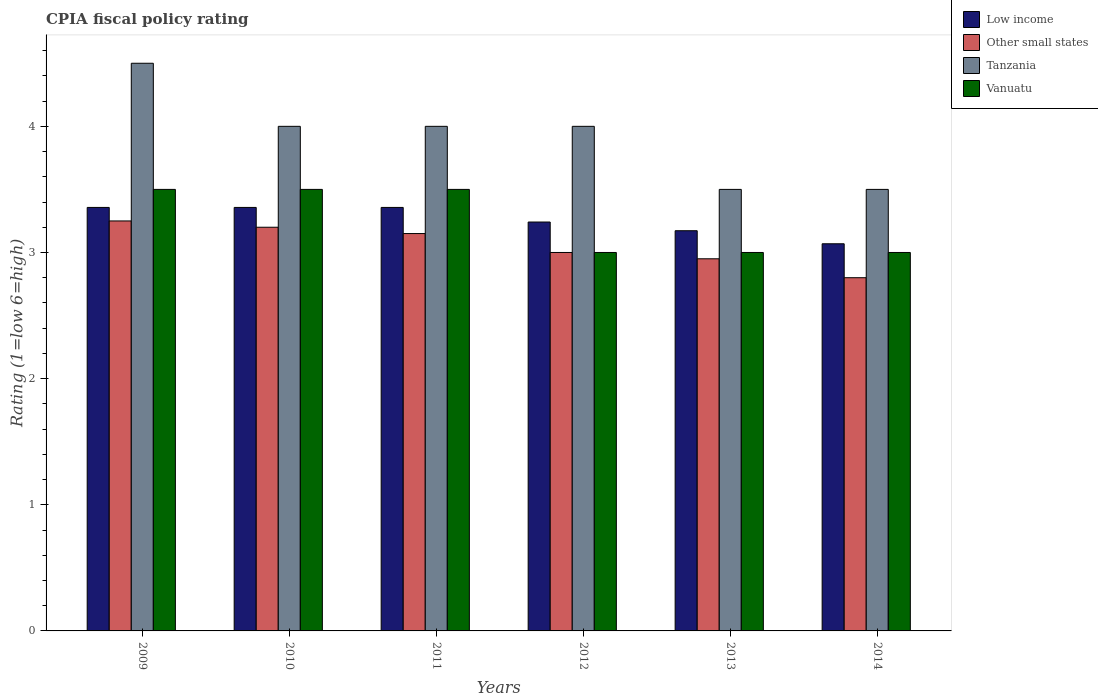Are the number of bars per tick equal to the number of legend labels?
Your answer should be very brief. Yes. How many bars are there on the 1st tick from the left?
Your response must be concise. 4. Across all years, what is the maximum CPIA rating in Vanuatu?
Give a very brief answer. 3.5. Across all years, what is the minimum CPIA rating in Tanzania?
Your answer should be very brief. 3.5. What is the total CPIA rating in Other small states in the graph?
Provide a succinct answer. 18.35. What is the difference between the CPIA rating in Low income in 2009 and that in 2014?
Keep it short and to the point. 0.29. What is the difference between the CPIA rating in Other small states in 2010 and the CPIA rating in Tanzania in 2013?
Provide a short and direct response. -0.3. In the year 2012, what is the difference between the CPIA rating in Tanzania and CPIA rating in Other small states?
Make the answer very short. 1. Is the CPIA rating in Vanuatu in 2010 less than that in 2012?
Offer a terse response. No. Is the difference between the CPIA rating in Tanzania in 2009 and 2010 greater than the difference between the CPIA rating in Other small states in 2009 and 2010?
Your response must be concise. Yes. What is the difference between the highest and the second highest CPIA rating in Tanzania?
Your response must be concise. 0.5. What is the difference between the highest and the lowest CPIA rating in Vanuatu?
Give a very brief answer. 0.5. In how many years, is the CPIA rating in Other small states greater than the average CPIA rating in Other small states taken over all years?
Your answer should be very brief. 3. What does the 2nd bar from the left in 2011 represents?
Provide a succinct answer. Other small states. What does the 1st bar from the right in 2011 represents?
Your response must be concise. Vanuatu. Is it the case that in every year, the sum of the CPIA rating in Low income and CPIA rating in Tanzania is greater than the CPIA rating in Vanuatu?
Make the answer very short. Yes. How many years are there in the graph?
Your answer should be compact. 6. Are the values on the major ticks of Y-axis written in scientific E-notation?
Your answer should be compact. No. Does the graph contain any zero values?
Offer a terse response. No. Where does the legend appear in the graph?
Your response must be concise. Top right. How many legend labels are there?
Your answer should be compact. 4. How are the legend labels stacked?
Provide a succinct answer. Vertical. What is the title of the graph?
Provide a succinct answer. CPIA fiscal policy rating. Does "Sri Lanka" appear as one of the legend labels in the graph?
Your answer should be very brief. No. What is the label or title of the X-axis?
Ensure brevity in your answer.  Years. What is the label or title of the Y-axis?
Your answer should be very brief. Rating (1=low 6=high). What is the Rating (1=low 6=high) of Low income in 2009?
Ensure brevity in your answer.  3.36. What is the Rating (1=low 6=high) in Other small states in 2009?
Provide a short and direct response. 3.25. What is the Rating (1=low 6=high) in Tanzania in 2009?
Offer a terse response. 4.5. What is the Rating (1=low 6=high) in Vanuatu in 2009?
Give a very brief answer. 3.5. What is the Rating (1=low 6=high) of Low income in 2010?
Give a very brief answer. 3.36. What is the Rating (1=low 6=high) of Other small states in 2010?
Give a very brief answer. 3.2. What is the Rating (1=low 6=high) of Low income in 2011?
Ensure brevity in your answer.  3.36. What is the Rating (1=low 6=high) of Other small states in 2011?
Keep it short and to the point. 3.15. What is the Rating (1=low 6=high) in Tanzania in 2011?
Provide a succinct answer. 4. What is the Rating (1=low 6=high) of Vanuatu in 2011?
Your answer should be compact. 3.5. What is the Rating (1=low 6=high) in Low income in 2012?
Offer a very short reply. 3.24. What is the Rating (1=low 6=high) in Vanuatu in 2012?
Ensure brevity in your answer.  3. What is the Rating (1=low 6=high) in Low income in 2013?
Your answer should be very brief. 3.17. What is the Rating (1=low 6=high) of Other small states in 2013?
Your response must be concise. 2.95. What is the Rating (1=low 6=high) of Vanuatu in 2013?
Your answer should be very brief. 3. What is the Rating (1=low 6=high) in Low income in 2014?
Offer a terse response. 3.07. What is the Rating (1=low 6=high) of Tanzania in 2014?
Offer a very short reply. 3.5. What is the Rating (1=low 6=high) in Vanuatu in 2014?
Your answer should be very brief. 3. Across all years, what is the maximum Rating (1=low 6=high) in Low income?
Offer a very short reply. 3.36. Across all years, what is the maximum Rating (1=low 6=high) of Tanzania?
Provide a succinct answer. 4.5. Across all years, what is the minimum Rating (1=low 6=high) in Low income?
Provide a succinct answer. 3.07. Across all years, what is the minimum Rating (1=low 6=high) of Tanzania?
Ensure brevity in your answer.  3.5. Across all years, what is the minimum Rating (1=low 6=high) in Vanuatu?
Your answer should be compact. 3. What is the total Rating (1=low 6=high) in Low income in the graph?
Your answer should be very brief. 19.55. What is the total Rating (1=low 6=high) of Other small states in the graph?
Offer a very short reply. 18.35. What is the total Rating (1=low 6=high) in Tanzania in the graph?
Provide a succinct answer. 23.5. What is the total Rating (1=low 6=high) in Vanuatu in the graph?
Give a very brief answer. 19.5. What is the difference between the Rating (1=low 6=high) in Other small states in 2009 and that in 2010?
Make the answer very short. 0.05. What is the difference between the Rating (1=low 6=high) in Tanzania in 2009 and that in 2011?
Make the answer very short. 0.5. What is the difference between the Rating (1=low 6=high) of Low income in 2009 and that in 2012?
Offer a terse response. 0.12. What is the difference between the Rating (1=low 6=high) of Other small states in 2009 and that in 2012?
Give a very brief answer. 0.25. What is the difference between the Rating (1=low 6=high) of Tanzania in 2009 and that in 2012?
Give a very brief answer. 0.5. What is the difference between the Rating (1=low 6=high) in Vanuatu in 2009 and that in 2012?
Your response must be concise. 0.5. What is the difference between the Rating (1=low 6=high) of Low income in 2009 and that in 2013?
Provide a succinct answer. 0.18. What is the difference between the Rating (1=low 6=high) in Other small states in 2009 and that in 2013?
Ensure brevity in your answer.  0.3. What is the difference between the Rating (1=low 6=high) in Vanuatu in 2009 and that in 2013?
Keep it short and to the point. 0.5. What is the difference between the Rating (1=low 6=high) of Low income in 2009 and that in 2014?
Make the answer very short. 0.29. What is the difference between the Rating (1=low 6=high) in Other small states in 2009 and that in 2014?
Offer a very short reply. 0.45. What is the difference between the Rating (1=low 6=high) in Vanuatu in 2010 and that in 2011?
Your response must be concise. 0. What is the difference between the Rating (1=low 6=high) of Low income in 2010 and that in 2012?
Ensure brevity in your answer.  0.12. What is the difference between the Rating (1=low 6=high) of Other small states in 2010 and that in 2012?
Make the answer very short. 0.2. What is the difference between the Rating (1=low 6=high) in Low income in 2010 and that in 2013?
Provide a short and direct response. 0.18. What is the difference between the Rating (1=low 6=high) of Other small states in 2010 and that in 2013?
Offer a very short reply. 0.25. What is the difference between the Rating (1=low 6=high) of Low income in 2010 and that in 2014?
Give a very brief answer. 0.29. What is the difference between the Rating (1=low 6=high) in Tanzania in 2010 and that in 2014?
Give a very brief answer. 0.5. What is the difference between the Rating (1=low 6=high) of Vanuatu in 2010 and that in 2014?
Provide a succinct answer. 0.5. What is the difference between the Rating (1=low 6=high) of Low income in 2011 and that in 2012?
Ensure brevity in your answer.  0.12. What is the difference between the Rating (1=low 6=high) in Other small states in 2011 and that in 2012?
Give a very brief answer. 0.15. What is the difference between the Rating (1=low 6=high) in Tanzania in 2011 and that in 2012?
Ensure brevity in your answer.  0. What is the difference between the Rating (1=low 6=high) in Vanuatu in 2011 and that in 2012?
Your response must be concise. 0.5. What is the difference between the Rating (1=low 6=high) in Low income in 2011 and that in 2013?
Your response must be concise. 0.18. What is the difference between the Rating (1=low 6=high) in Other small states in 2011 and that in 2013?
Provide a short and direct response. 0.2. What is the difference between the Rating (1=low 6=high) in Vanuatu in 2011 and that in 2013?
Provide a short and direct response. 0.5. What is the difference between the Rating (1=low 6=high) of Low income in 2011 and that in 2014?
Ensure brevity in your answer.  0.29. What is the difference between the Rating (1=low 6=high) in Tanzania in 2011 and that in 2014?
Keep it short and to the point. 0.5. What is the difference between the Rating (1=low 6=high) in Low income in 2012 and that in 2013?
Offer a terse response. 0.07. What is the difference between the Rating (1=low 6=high) of Vanuatu in 2012 and that in 2013?
Keep it short and to the point. 0. What is the difference between the Rating (1=low 6=high) of Low income in 2012 and that in 2014?
Your response must be concise. 0.17. What is the difference between the Rating (1=low 6=high) in Other small states in 2012 and that in 2014?
Your response must be concise. 0.2. What is the difference between the Rating (1=low 6=high) in Tanzania in 2012 and that in 2014?
Provide a succinct answer. 0.5. What is the difference between the Rating (1=low 6=high) in Low income in 2013 and that in 2014?
Offer a very short reply. 0.1. What is the difference between the Rating (1=low 6=high) of Other small states in 2013 and that in 2014?
Keep it short and to the point. 0.15. What is the difference between the Rating (1=low 6=high) of Tanzania in 2013 and that in 2014?
Ensure brevity in your answer.  0. What is the difference between the Rating (1=low 6=high) of Vanuatu in 2013 and that in 2014?
Give a very brief answer. 0. What is the difference between the Rating (1=low 6=high) of Low income in 2009 and the Rating (1=low 6=high) of Other small states in 2010?
Offer a terse response. 0.16. What is the difference between the Rating (1=low 6=high) of Low income in 2009 and the Rating (1=low 6=high) of Tanzania in 2010?
Your answer should be very brief. -0.64. What is the difference between the Rating (1=low 6=high) of Low income in 2009 and the Rating (1=low 6=high) of Vanuatu in 2010?
Your response must be concise. -0.14. What is the difference between the Rating (1=low 6=high) in Other small states in 2009 and the Rating (1=low 6=high) in Tanzania in 2010?
Give a very brief answer. -0.75. What is the difference between the Rating (1=low 6=high) of Tanzania in 2009 and the Rating (1=low 6=high) of Vanuatu in 2010?
Keep it short and to the point. 1. What is the difference between the Rating (1=low 6=high) of Low income in 2009 and the Rating (1=low 6=high) of Other small states in 2011?
Give a very brief answer. 0.21. What is the difference between the Rating (1=low 6=high) of Low income in 2009 and the Rating (1=low 6=high) of Tanzania in 2011?
Keep it short and to the point. -0.64. What is the difference between the Rating (1=low 6=high) of Low income in 2009 and the Rating (1=low 6=high) of Vanuatu in 2011?
Keep it short and to the point. -0.14. What is the difference between the Rating (1=low 6=high) of Other small states in 2009 and the Rating (1=low 6=high) of Tanzania in 2011?
Offer a terse response. -0.75. What is the difference between the Rating (1=low 6=high) in Tanzania in 2009 and the Rating (1=low 6=high) in Vanuatu in 2011?
Give a very brief answer. 1. What is the difference between the Rating (1=low 6=high) in Low income in 2009 and the Rating (1=low 6=high) in Other small states in 2012?
Ensure brevity in your answer.  0.36. What is the difference between the Rating (1=low 6=high) in Low income in 2009 and the Rating (1=low 6=high) in Tanzania in 2012?
Provide a short and direct response. -0.64. What is the difference between the Rating (1=low 6=high) in Low income in 2009 and the Rating (1=low 6=high) in Vanuatu in 2012?
Keep it short and to the point. 0.36. What is the difference between the Rating (1=low 6=high) of Other small states in 2009 and the Rating (1=low 6=high) of Tanzania in 2012?
Make the answer very short. -0.75. What is the difference between the Rating (1=low 6=high) of Other small states in 2009 and the Rating (1=low 6=high) of Vanuatu in 2012?
Offer a terse response. 0.25. What is the difference between the Rating (1=low 6=high) of Tanzania in 2009 and the Rating (1=low 6=high) of Vanuatu in 2012?
Offer a very short reply. 1.5. What is the difference between the Rating (1=low 6=high) in Low income in 2009 and the Rating (1=low 6=high) in Other small states in 2013?
Provide a short and direct response. 0.41. What is the difference between the Rating (1=low 6=high) in Low income in 2009 and the Rating (1=low 6=high) in Tanzania in 2013?
Provide a succinct answer. -0.14. What is the difference between the Rating (1=low 6=high) in Low income in 2009 and the Rating (1=low 6=high) in Vanuatu in 2013?
Make the answer very short. 0.36. What is the difference between the Rating (1=low 6=high) in Other small states in 2009 and the Rating (1=low 6=high) in Tanzania in 2013?
Offer a very short reply. -0.25. What is the difference between the Rating (1=low 6=high) of Other small states in 2009 and the Rating (1=low 6=high) of Vanuatu in 2013?
Keep it short and to the point. 0.25. What is the difference between the Rating (1=low 6=high) in Low income in 2009 and the Rating (1=low 6=high) in Other small states in 2014?
Give a very brief answer. 0.56. What is the difference between the Rating (1=low 6=high) of Low income in 2009 and the Rating (1=low 6=high) of Tanzania in 2014?
Offer a terse response. -0.14. What is the difference between the Rating (1=low 6=high) in Low income in 2009 and the Rating (1=low 6=high) in Vanuatu in 2014?
Offer a very short reply. 0.36. What is the difference between the Rating (1=low 6=high) of Other small states in 2009 and the Rating (1=low 6=high) of Vanuatu in 2014?
Your response must be concise. 0.25. What is the difference between the Rating (1=low 6=high) of Low income in 2010 and the Rating (1=low 6=high) of Other small states in 2011?
Keep it short and to the point. 0.21. What is the difference between the Rating (1=low 6=high) of Low income in 2010 and the Rating (1=low 6=high) of Tanzania in 2011?
Offer a very short reply. -0.64. What is the difference between the Rating (1=low 6=high) of Low income in 2010 and the Rating (1=low 6=high) of Vanuatu in 2011?
Offer a terse response. -0.14. What is the difference between the Rating (1=low 6=high) in Other small states in 2010 and the Rating (1=low 6=high) in Tanzania in 2011?
Your answer should be compact. -0.8. What is the difference between the Rating (1=low 6=high) of Low income in 2010 and the Rating (1=low 6=high) of Other small states in 2012?
Offer a very short reply. 0.36. What is the difference between the Rating (1=low 6=high) of Low income in 2010 and the Rating (1=low 6=high) of Tanzania in 2012?
Your answer should be very brief. -0.64. What is the difference between the Rating (1=low 6=high) of Low income in 2010 and the Rating (1=low 6=high) of Vanuatu in 2012?
Give a very brief answer. 0.36. What is the difference between the Rating (1=low 6=high) of Other small states in 2010 and the Rating (1=low 6=high) of Tanzania in 2012?
Give a very brief answer. -0.8. What is the difference between the Rating (1=low 6=high) in Tanzania in 2010 and the Rating (1=low 6=high) in Vanuatu in 2012?
Offer a very short reply. 1. What is the difference between the Rating (1=low 6=high) in Low income in 2010 and the Rating (1=low 6=high) in Other small states in 2013?
Offer a very short reply. 0.41. What is the difference between the Rating (1=low 6=high) in Low income in 2010 and the Rating (1=low 6=high) in Tanzania in 2013?
Ensure brevity in your answer.  -0.14. What is the difference between the Rating (1=low 6=high) of Low income in 2010 and the Rating (1=low 6=high) of Vanuatu in 2013?
Your answer should be very brief. 0.36. What is the difference between the Rating (1=low 6=high) in Other small states in 2010 and the Rating (1=low 6=high) in Tanzania in 2013?
Offer a terse response. -0.3. What is the difference between the Rating (1=low 6=high) in Low income in 2010 and the Rating (1=low 6=high) in Other small states in 2014?
Your answer should be very brief. 0.56. What is the difference between the Rating (1=low 6=high) in Low income in 2010 and the Rating (1=low 6=high) in Tanzania in 2014?
Offer a very short reply. -0.14. What is the difference between the Rating (1=low 6=high) in Low income in 2010 and the Rating (1=low 6=high) in Vanuatu in 2014?
Ensure brevity in your answer.  0.36. What is the difference between the Rating (1=low 6=high) in Other small states in 2010 and the Rating (1=low 6=high) in Vanuatu in 2014?
Ensure brevity in your answer.  0.2. What is the difference between the Rating (1=low 6=high) in Tanzania in 2010 and the Rating (1=low 6=high) in Vanuatu in 2014?
Offer a very short reply. 1. What is the difference between the Rating (1=low 6=high) of Low income in 2011 and the Rating (1=low 6=high) of Other small states in 2012?
Ensure brevity in your answer.  0.36. What is the difference between the Rating (1=low 6=high) of Low income in 2011 and the Rating (1=low 6=high) of Tanzania in 2012?
Your response must be concise. -0.64. What is the difference between the Rating (1=low 6=high) of Low income in 2011 and the Rating (1=low 6=high) of Vanuatu in 2012?
Provide a short and direct response. 0.36. What is the difference between the Rating (1=low 6=high) of Other small states in 2011 and the Rating (1=low 6=high) of Tanzania in 2012?
Make the answer very short. -0.85. What is the difference between the Rating (1=low 6=high) of Low income in 2011 and the Rating (1=low 6=high) of Other small states in 2013?
Offer a terse response. 0.41. What is the difference between the Rating (1=low 6=high) in Low income in 2011 and the Rating (1=low 6=high) in Tanzania in 2013?
Your answer should be compact. -0.14. What is the difference between the Rating (1=low 6=high) in Low income in 2011 and the Rating (1=low 6=high) in Vanuatu in 2013?
Provide a short and direct response. 0.36. What is the difference between the Rating (1=low 6=high) in Other small states in 2011 and the Rating (1=low 6=high) in Tanzania in 2013?
Offer a terse response. -0.35. What is the difference between the Rating (1=low 6=high) in Other small states in 2011 and the Rating (1=low 6=high) in Vanuatu in 2013?
Ensure brevity in your answer.  0.15. What is the difference between the Rating (1=low 6=high) of Tanzania in 2011 and the Rating (1=low 6=high) of Vanuatu in 2013?
Provide a succinct answer. 1. What is the difference between the Rating (1=low 6=high) in Low income in 2011 and the Rating (1=low 6=high) in Other small states in 2014?
Give a very brief answer. 0.56. What is the difference between the Rating (1=low 6=high) in Low income in 2011 and the Rating (1=low 6=high) in Tanzania in 2014?
Give a very brief answer. -0.14. What is the difference between the Rating (1=low 6=high) of Low income in 2011 and the Rating (1=low 6=high) of Vanuatu in 2014?
Offer a very short reply. 0.36. What is the difference between the Rating (1=low 6=high) in Other small states in 2011 and the Rating (1=low 6=high) in Tanzania in 2014?
Your answer should be compact. -0.35. What is the difference between the Rating (1=low 6=high) of Low income in 2012 and the Rating (1=low 6=high) of Other small states in 2013?
Offer a terse response. 0.29. What is the difference between the Rating (1=low 6=high) in Low income in 2012 and the Rating (1=low 6=high) in Tanzania in 2013?
Your answer should be very brief. -0.26. What is the difference between the Rating (1=low 6=high) in Low income in 2012 and the Rating (1=low 6=high) in Vanuatu in 2013?
Offer a very short reply. 0.24. What is the difference between the Rating (1=low 6=high) of Other small states in 2012 and the Rating (1=low 6=high) of Tanzania in 2013?
Offer a very short reply. -0.5. What is the difference between the Rating (1=low 6=high) of Other small states in 2012 and the Rating (1=low 6=high) of Vanuatu in 2013?
Keep it short and to the point. 0. What is the difference between the Rating (1=low 6=high) in Tanzania in 2012 and the Rating (1=low 6=high) in Vanuatu in 2013?
Make the answer very short. 1. What is the difference between the Rating (1=low 6=high) of Low income in 2012 and the Rating (1=low 6=high) of Other small states in 2014?
Provide a succinct answer. 0.44. What is the difference between the Rating (1=low 6=high) of Low income in 2012 and the Rating (1=low 6=high) of Tanzania in 2014?
Ensure brevity in your answer.  -0.26. What is the difference between the Rating (1=low 6=high) in Low income in 2012 and the Rating (1=low 6=high) in Vanuatu in 2014?
Make the answer very short. 0.24. What is the difference between the Rating (1=low 6=high) of Other small states in 2012 and the Rating (1=low 6=high) of Vanuatu in 2014?
Offer a very short reply. 0. What is the difference between the Rating (1=low 6=high) of Low income in 2013 and the Rating (1=low 6=high) of Other small states in 2014?
Make the answer very short. 0.37. What is the difference between the Rating (1=low 6=high) of Low income in 2013 and the Rating (1=low 6=high) of Tanzania in 2014?
Your response must be concise. -0.33. What is the difference between the Rating (1=low 6=high) of Low income in 2013 and the Rating (1=low 6=high) of Vanuatu in 2014?
Make the answer very short. 0.17. What is the difference between the Rating (1=low 6=high) in Other small states in 2013 and the Rating (1=low 6=high) in Tanzania in 2014?
Provide a short and direct response. -0.55. What is the difference between the Rating (1=low 6=high) in Other small states in 2013 and the Rating (1=low 6=high) in Vanuatu in 2014?
Your answer should be very brief. -0.05. What is the average Rating (1=low 6=high) in Low income per year?
Provide a succinct answer. 3.26. What is the average Rating (1=low 6=high) in Other small states per year?
Offer a very short reply. 3.06. What is the average Rating (1=low 6=high) in Tanzania per year?
Provide a succinct answer. 3.92. What is the average Rating (1=low 6=high) of Vanuatu per year?
Your answer should be compact. 3.25. In the year 2009, what is the difference between the Rating (1=low 6=high) of Low income and Rating (1=low 6=high) of Other small states?
Keep it short and to the point. 0.11. In the year 2009, what is the difference between the Rating (1=low 6=high) in Low income and Rating (1=low 6=high) in Tanzania?
Ensure brevity in your answer.  -1.14. In the year 2009, what is the difference between the Rating (1=low 6=high) of Low income and Rating (1=low 6=high) of Vanuatu?
Your answer should be compact. -0.14. In the year 2009, what is the difference between the Rating (1=low 6=high) in Other small states and Rating (1=low 6=high) in Tanzania?
Keep it short and to the point. -1.25. In the year 2009, what is the difference between the Rating (1=low 6=high) in Tanzania and Rating (1=low 6=high) in Vanuatu?
Keep it short and to the point. 1. In the year 2010, what is the difference between the Rating (1=low 6=high) of Low income and Rating (1=low 6=high) of Other small states?
Your answer should be compact. 0.16. In the year 2010, what is the difference between the Rating (1=low 6=high) of Low income and Rating (1=low 6=high) of Tanzania?
Keep it short and to the point. -0.64. In the year 2010, what is the difference between the Rating (1=low 6=high) in Low income and Rating (1=low 6=high) in Vanuatu?
Provide a succinct answer. -0.14. In the year 2010, what is the difference between the Rating (1=low 6=high) of Other small states and Rating (1=low 6=high) of Tanzania?
Your answer should be compact. -0.8. In the year 2010, what is the difference between the Rating (1=low 6=high) of Tanzania and Rating (1=low 6=high) of Vanuatu?
Offer a terse response. 0.5. In the year 2011, what is the difference between the Rating (1=low 6=high) of Low income and Rating (1=low 6=high) of Other small states?
Your answer should be very brief. 0.21. In the year 2011, what is the difference between the Rating (1=low 6=high) of Low income and Rating (1=low 6=high) of Tanzania?
Make the answer very short. -0.64. In the year 2011, what is the difference between the Rating (1=low 6=high) of Low income and Rating (1=low 6=high) of Vanuatu?
Your answer should be compact. -0.14. In the year 2011, what is the difference between the Rating (1=low 6=high) in Other small states and Rating (1=low 6=high) in Tanzania?
Offer a terse response. -0.85. In the year 2011, what is the difference between the Rating (1=low 6=high) of Other small states and Rating (1=low 6=high) of Vanuatu?
Keep it short and to the point. -0.35. In the year 2011, what is the difference between the Rating (1=low 6=high) of Tanzania and Rating (1=low 6=high) of Vanuatu?
Provide a short and direct response. 0.5. In the year 2012, what is the difference between the Rating (1=low 6=high) in Low income and Rating (1=low 6=high) in Other small states?
Offer a very short reply. 0.24. In the year 2012, what is the difference between the Rating (1=low 6=high) of Low income and Rating (1=low 6=high) of Tanzania?
Ensure brevity in your answer.  -0.76. In the year 2012, what is the difference between the Rating (1=low 6=high) in Low income and Rating (1=low 6=high) in Vanuatu?
Offer a very short reply. 0.24. In the year 2012, what is the difference between the Rating (1=low 6=high) in Tanzania and Rating (1=low 6=high) in Vanuatu?
Give a very brief answer. 1. In the year 2013, what is the difference between the Rating (1=low 6=high) in Low income and Rating (1=low 6=high) in Other small states?
Make the answer very short. 0.22. In the year 2013, what is the difference between the Rating (1=low 6=high) in Low income and Rating (1=low 6=high) in Tanzania?
Make the answer very short. -0.33. In the year 2013, what is the difference between the Rating (1=low 6=high) of Low income and Rating (1=low 6=high) of Vanuatu?
Your answer should be compact. 0.17. In the year 2013, what is the difference between the Rating (1=low 6=high) of Other small states and Rating (1=low 6=high) of Tanzania?
Offer a very short reply. -0.55. In the year 2013, what is the difference between the Rating (1=low 6=high) of Tanzania and Rating (1=low 6=high) of Vanuatu?
Make the answer very short. 0.5. In the year 2014, what is the difference between the Rating (1=low 6=high) in Low income and Rating (1=low 6=high) in Other small states?
Your answer should be compact. 0.27. In the year 2014, what is the difference between the Rating (1=low 6=high) in Low income and Rating (1=low 6=high) in Tanzania?
Keep it short and to the point. -0.43. In the year 2014, what is the difference between the Rating (1=low 6=high) in Low income and Rating (1=low 6=high) in Vanuatu?
Make the answer very short. 0.07. In the year 2014, what is the difference between the Rating (1=low 6=high) of Other small states and Rating (1=low 6=high) of Tanzania?
Offer a terse response. -0.7. In the year 2014, what is the difference between the Rating (1=low 6=high) in Other small states and Rating (1=low 6=high) in Vanuatu?
Keep it short and to the point. -0.2. What is the ratio of the Rating (1=low 6=high) of Low income in 2009 to that in 2010?
Offer a terse response. 1. What is the ratio of the Rating (1=low 6=high) of Other small states in 2009 to that in 2010?
Give a very brief answer. 1.02. What is the ratio of the Rating (1=low 6=high) of Tanzania in 2009 to that in 2010?
Offer a very short reply. 1.12. What is the ratio of the Rating (1=low 6=high) of Vanuatu in 2009 to that in 2010?
Keep it short and to the point. 1. What is the ratio of the Rating (1=low 6=high) of Other small states in 2009 to that in 2011?
Your answer should be compact. 1.03. What is the ratio of the Rating (1=low 6=high) of Vanuatu in 2009 to that in 2011?
Your response must be concise. 1. What is the ratio of the Rating (1=low 6=high) in Low income in 2009 to that in 2012?
Your response must be concise. 1.04. What is the ratio of the Rating (1=low 6=high) of Other small states in 2009 to that in 2012?
Keep it short and to the point. 1.08. What is the ratio of the Rating (1=low 6=high) of Tanzania in 2009 to that in 2012?
Your answer should be compact. 1.12. What is the ratio of the Rating (1=low 6=high) in Vanuatu in 2009 to that in 2012?
Ensure brevity in your answer.  1.17. What is the ratio of the Rating (1=low 6=high) in Low income in 2009 to that in 2013?
Keep it short and to the point. 1.06. What is the ratio of the Rating (1=low 6=high) in Other small states in 2009 to that in 2013?
Offer a terse response. 1.1. What is the ratio of the Rating (1=low 6=high) in Tanzania in 2009 to that in 2013?
Your response must be concise. 1.29. What is the ratio of the Rating (1=low 6=high) of Low income in 2009 to that in 2014?
Your response must be concise. 1.09. What is the ratio of the Rating (1=low 6=high) of Other small states in 2009 to that in 2014?
Your answer should be very brief. 1.16. What is the ratio of the Rating (1=low 6=high) in Vanuatu in 2009 to that in 2014?
Your answer should be compact. 1.17. What is the ratio of the Rating (1=low 6=high) of Low income in 2010 to that in 2011?
Your answer should be compact. 1. What is the ratio of the Rating (1=low 6=high) in Other small states in 2010 to that in 2011?
Provide a succinct answer. 1.02. What is the ratio of the Rating (1=low 6=high) of Vanuatu in 2010 to that in 2011?
Provide a succinct answer. 1. What is the ratio of the Rating (1=low 6=high) in Low income in 2010 to that in 2012?
Your answer should be compact. 1.04. What is the ratio of the Rating (1=low 6=high) of Other small states in 2010 to that in 2012?
Ensure brevity in your answer.  1.07. What is the ratio of the Rating (1=low 6=high) of Tanzania in 2010 to that in 2012?
Provide a short and direct response. 1. What is the ratio of the Rating (1=low 6=high) of Vanuatu in 2010 to that in 2012?
Ensure brevity in your answer.  1.17. What is the ratio of the Rating (1=low 6=high) of Low income in 2010 to that in 2013?
Make the answer very short. 1.06. What is the ratio of the Rating (1=low 6=high) of Other small states in 2010 to that in 2013?
Provide a succinct answer. 1.08. What is the ratio of the Rating (1=low 6=high) of Tanzania in 2010 to that in 2013?
Your answer should be compact. 1.14. What is the ratio of the Rating (1=low 6=high) of Low income in 2010 to that in 2014?
Your answer should be very brief. 1.09. What is the ratio of the Rating (1=low 6=high) in Other small states in 2010 to that in 2014?
Make the answer very short. 1.14. What is the ratio of the Rating (1=low 6=high) of Tanzania in 2010 to that in 2014?
Provide a succinct answer. 1.14. What is the ratio of the Rating (1=low 6=high) of Vanuatu in 2010 to that in 2014?
Your answer should be compact. 1.17. What is the ratio of the Rating (1=low 6=high) in Low income in 2011 to that in 2012?
Make the answer very short. 1.04. What is the ratio of the Rating (1=low 6=high) of Tanzania in 2011 to that in 2012?
Your answer should be compact. 1. What is the ratio of the Rating (1=low 6=high) in Low income in 2011 to that in 2013?
Provide a short and direct response. 1.06. What is the ratio of the Rating (1=low 6=high) of Other small states in 2011 to that in 2013?
Give a very brief answer. 1.07. What is the ratio of the Rating (1=low 6=high) in Tanzania in 2011 to that in 2013?
Your answer should be very brief. 1.14. What is the ratio of the Rating (1=low 6=high) in Low income in 2011 to that in 2014?
Offer a very short reply. 1.09. What is the ratio of the Rating (1=low 6=high) of Low income in 2012 to that in 2013?
Your response must be concise. 1.02. What is the ratio of the Rating (1=low 6=high) in Other small states in 2012 to that in 2013?
Offer a terse response. 1.02. What is the ratio of the Rating (1=low 6=high) of Tanzania in 2012 to that in 2013?
Offer a very short reply. 1.14. What is the ratio of the Rating (1=low 6=high) of Vanuatu in 2012 to that in 2013?
Your response must be concise. 1. What is the ratio of the Rating (1=low 6=high) in Low income in 2012 to that in 2014?
Your response must be concise. 1.06. What is the ratio of the Rating (1=low 6=high) of Other small states in 2012 to that in 2014?
Offer a terse response. 1.07. What is the ratio of the Rating (1=low 6=high) in Tanzania in 2012 to that in 2014?
Ensure brevity in your answer.  1.14. What is the ratio of the Rating (1=low 6=high) of Vanuatu in 2012 to that in 2014?
Make the answer very short. 1. What is the ratio of the Rating (1=low 6=high) of Low income in 2013 to that in 2014?
Ensure brevity in your answer.  1.03. What is the ratio of the Rating (1=low 6=high) of Other small states in 2013 to that in 2014?
Provide a short and direct response. 1.05. What is the ratio of the Rating (1=low 6=high) in Tanzania in 2013 to that in 2014?
Ensure brevity in your answer.  1. What is the ratio of the Rating (1=low 6=high) in Vanuatu in 2013 to that in 2014?
Offer a very short reply. 1. What is the difference between the highest and the lowest Rating (1=low 6=high) in Low income?
Offer a terse response. 0.29. What is the difference between the highest and the lowest Rating (1=low 6=high) of Other small states?
Your answer should be very brief. 0.45. What is the difference between the highest and the lowest Rating (1=low 6=high) of Vanuatu?
Offer a terse response. 0.5. 